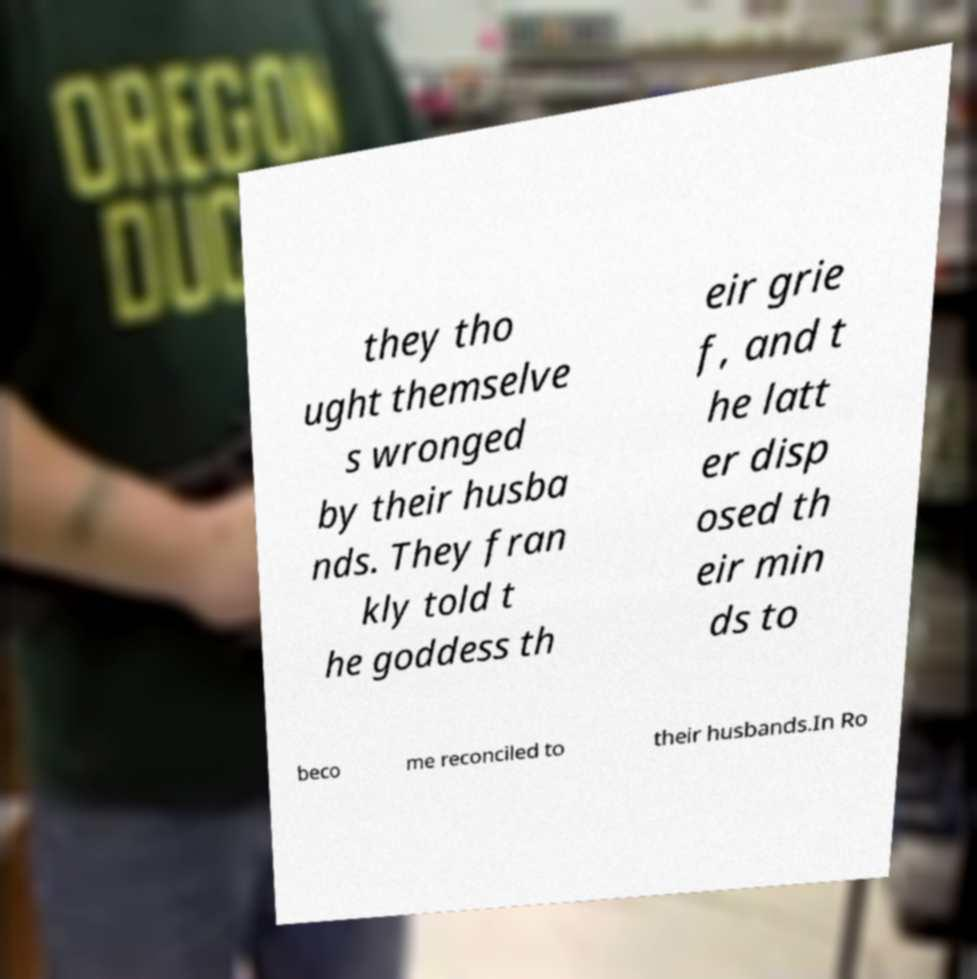Could you extract and type out the text from this image? they tho ught themselve s wronged by their husba nds. They fran kly told t he goddess th eir grie f, and t he latt er disp osed th eir min ds to beco me reconciled to their husbands.In Ro 